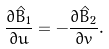<formula> <loc_0><loc_0><loc_500><loc_500>\frac { \partial \hat { B } _ { 1 } } { \partial u } = - \frac { \partial \hat { B } _ { 2 } } { \partial v } .</formula> 